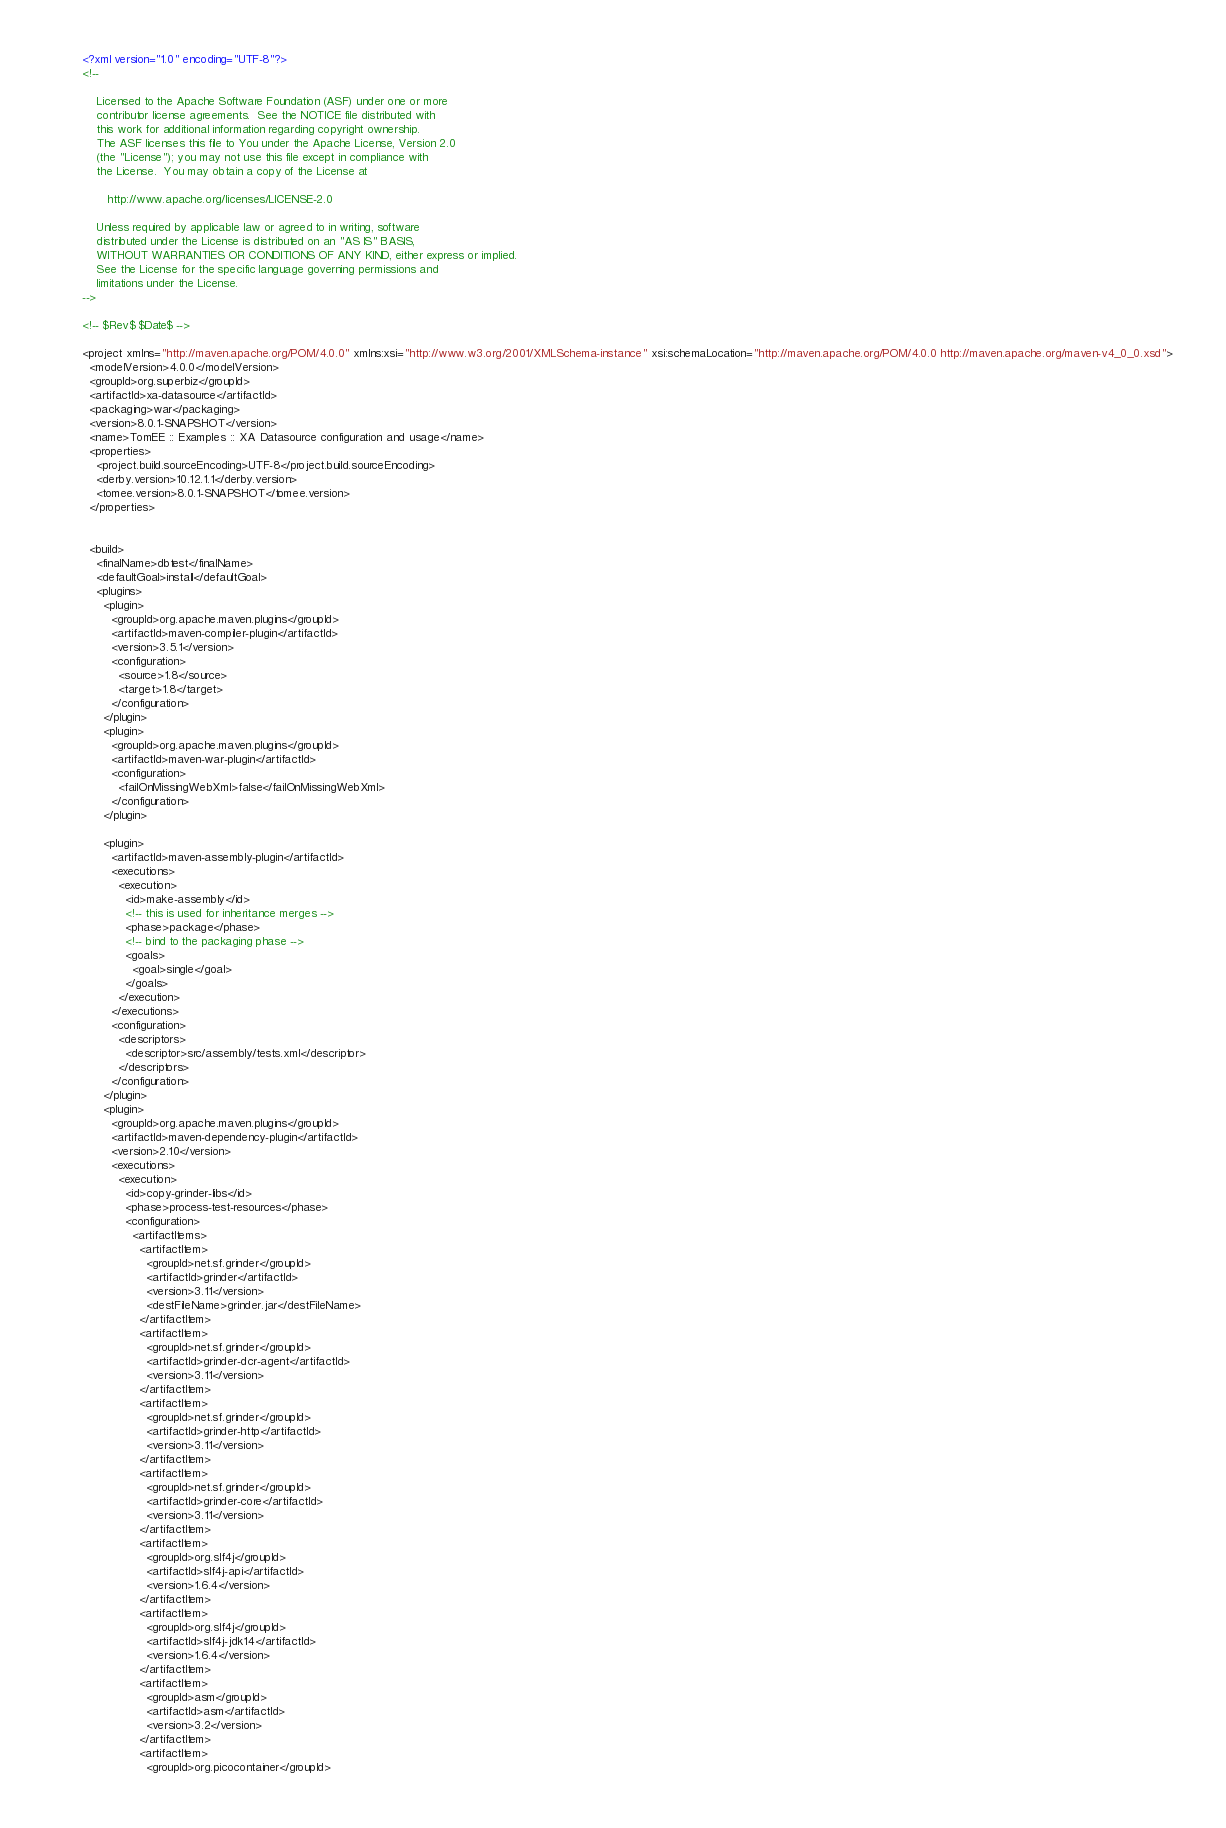Convert code to text. <code><loc_0><loc_0><loc_500><loc_500><_XML_><?xml version="1.0" encoding="UTF-8"?>
<!--

    Licensed to the Apache Software Foundation (ASF) under one or more
    contributor license agreements.  See the NOTICE file distributed with
    this work for additional information regarding copyright ownership.
    The ASF licenses this file to You under the Apache License, Version 2.0
    (the "License"); you may not use this file except in compliance with
    the License.  You may obtain a copy of the License at

       http://www.apache.org/licenses/LICENSE-2.0

    Unless required by applicable law or agreed to in writing, software
    distributed under the License is distributed on an "AS IS" BASIS,
    WITHOUT WARRANTIES OR CONDITIONS OF ANY KIND, either express or implied.
    See the License for the specific language governing permissions and
    limitations under the License.
-->

<!-- $Rev$ $Date$ -->

<project xmlns="http://maven.apache.org/POM/4.0.0" xmlns:xsi="http://www.w3.org/2001/XMLSchema-instance" xsi:schemaLocation="http://maven.apache.org/POM/4.0.0 http://maven.apache.org/maven-v4_0_0.xsd">
  <modelVersion>4.0.0</modelVersion>
  <groupId>org.superbiz</groupId>
  <artifactId>xa-datasource</artifactId>
  <packaging>war</packaging>
  <version>8.0.1-SNAPSHOT</version>
  <name>TomEE :: Examples :: XA Datasource configuration and usage</name>
  <properties>
    <project.build.sourceEncoding>UTF-8</project.build.sourceEncoding>
    <derby.version>10.12.1.1</derby.version>
    <tomee.version>8.0.1-SNAPSHOT</tomee.version>
  </properties>


  <build>
    <finalName>dbtest</finalName>
    <defaultGoal>install</defaultGoal>
    <plugins>
      <plugin>
        <groupId>org.apache.maven.plugins</groupId>
        <artifactId>maven-compiler-plugin</artifactId>
        <version>3.5.1</version>
        <configuration>
          <source>1.8</source>
          <target>1.8</target>
        </configuration>
      </plugin>
      <plugin>
        <groupId>org.apache.maven.plugins</groupId>
        <artifactId>maven-war-plugin</artifactId>
        <configuration>
          <failOnMissingWebXml>false</failOnMissingWebXml>
        </configuration>
      </plugin>

      <plugin>
        <artifactId>maven-assembly-plugin</artifactId>
        <executions>
          <execution>
            <id>make-assembly</id>
            <!-- this is used for inheritance merges -->
            <phase>package</phase>
            <!-- bind to the packaging phase -->
            <goals>
              <goal>single</goal>
            </goals>
          </execution>
        </executions>
        <configuration>
          <descriptors>
            <descriptor>src/assembly/tests.xml</descriptor>
          </descriptors>
        </configuration>
      </plugin>
      <plugin>
        <groupId>org.apache.maven.plugins</groupId>
        <artifactId>maven-dependency-plugin</artifactId>
        <version>2.10</version>
        <executions>
          <execution>
            <id>copy-grinder-libs</id>
            <phase>process-test-resources</phase>
            <configuration>
              <artifactItems>
                <artifactItem>
                  <groupId>net.sf.grinder</groupId>
                  <artifactId>grinder</artifactId>
                  <version>3.11</version>
                  <destFileName>grinder.jar</destFileName>
                </artifactItem>
                <artifactItem>
                  <groupId>net.sf.grinder</groupId>
                  <artifactId>grinder-dcr-agent</artifactId>
                  <version>3.11</version>
                </artifactItem>
                <artifactItem>
                  <groupId>net.sf.grinder</groupId>
                  <artifactId>grinder-http</artifactId>
                  <version>3.11</version>
                </artifactItem>
                <artifactItem>
                  <groupId>net.sf.grinder</groupId>
                  <artifactId>grinder-core</artifactId>
                  <version>3.11</version>
                </artifactItem>
                <artifactItem>
                  <groupId>org.slf4j</groupId>
                  <artifactId>slf4j-api</artifactId>
                  <version>1.6.4</version>
                </artifactItem>
                <artifactItem>
                  <groupId>org.slf4j</groupId>
                  <artifactId>slf4j-jdk14</artifactId>
                  <version>1.6.4</version>
                </artifactItem>
                <artifactItem>
                  <groupId>asm</groupId>
                  <artifactId>asm</artifactId>
                  <version>3.2</version>
                </artifactItem>
                <artifactItem>
                  <groupId>org.picocontainer</groupId></code> 